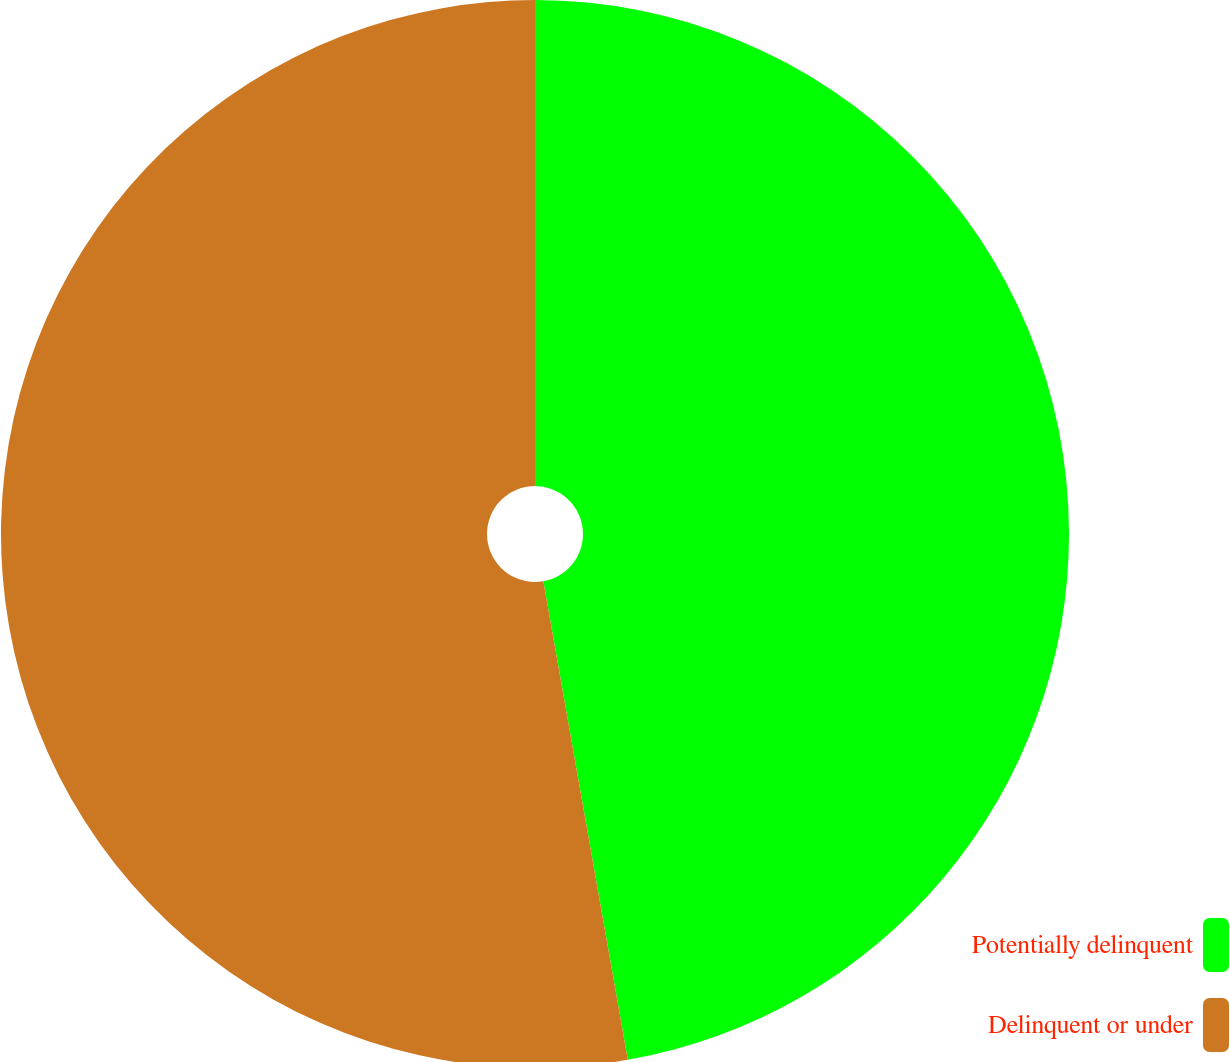<chart> <loc_0><loc_0><loc_500><loc_500><pie_chart><fcel>Potentially delinquent<fcel>Delinquent or under<nl><fcel>47.22%<fcel>52.78%<nl></chart> 